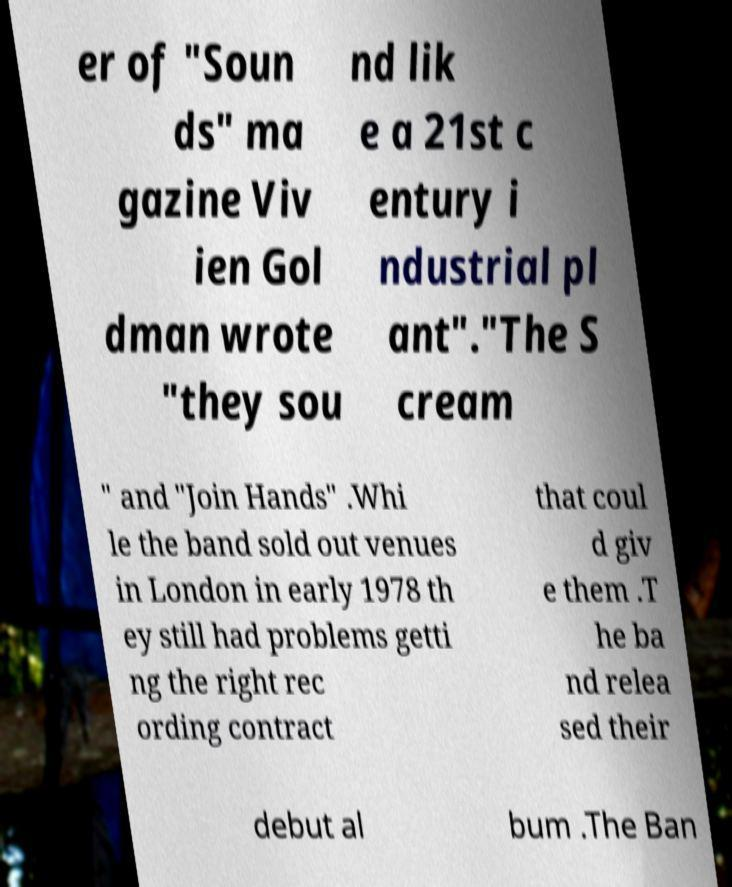Can you read and provide the text displayed in the image?This photo seems to have some interesting text. Can you extract and type it out for me? er of "Soun ds" ma gazine Viv ien Gol dman wrote "they sou nd lik e a 21st c entury i ndustrial pl ant"."The S cream " and "Join Hands" .Whi le the band sold out venues in London in early 1978 th ey still had problems getti ng the right rec ording contract that coul d giv e them .T he ba nd relea sed their debut al bum .The Ban 